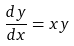<formula> <loc_0><loc_0><loc_500><loc_500>\frac { d y } { d x } = x y</formula> 